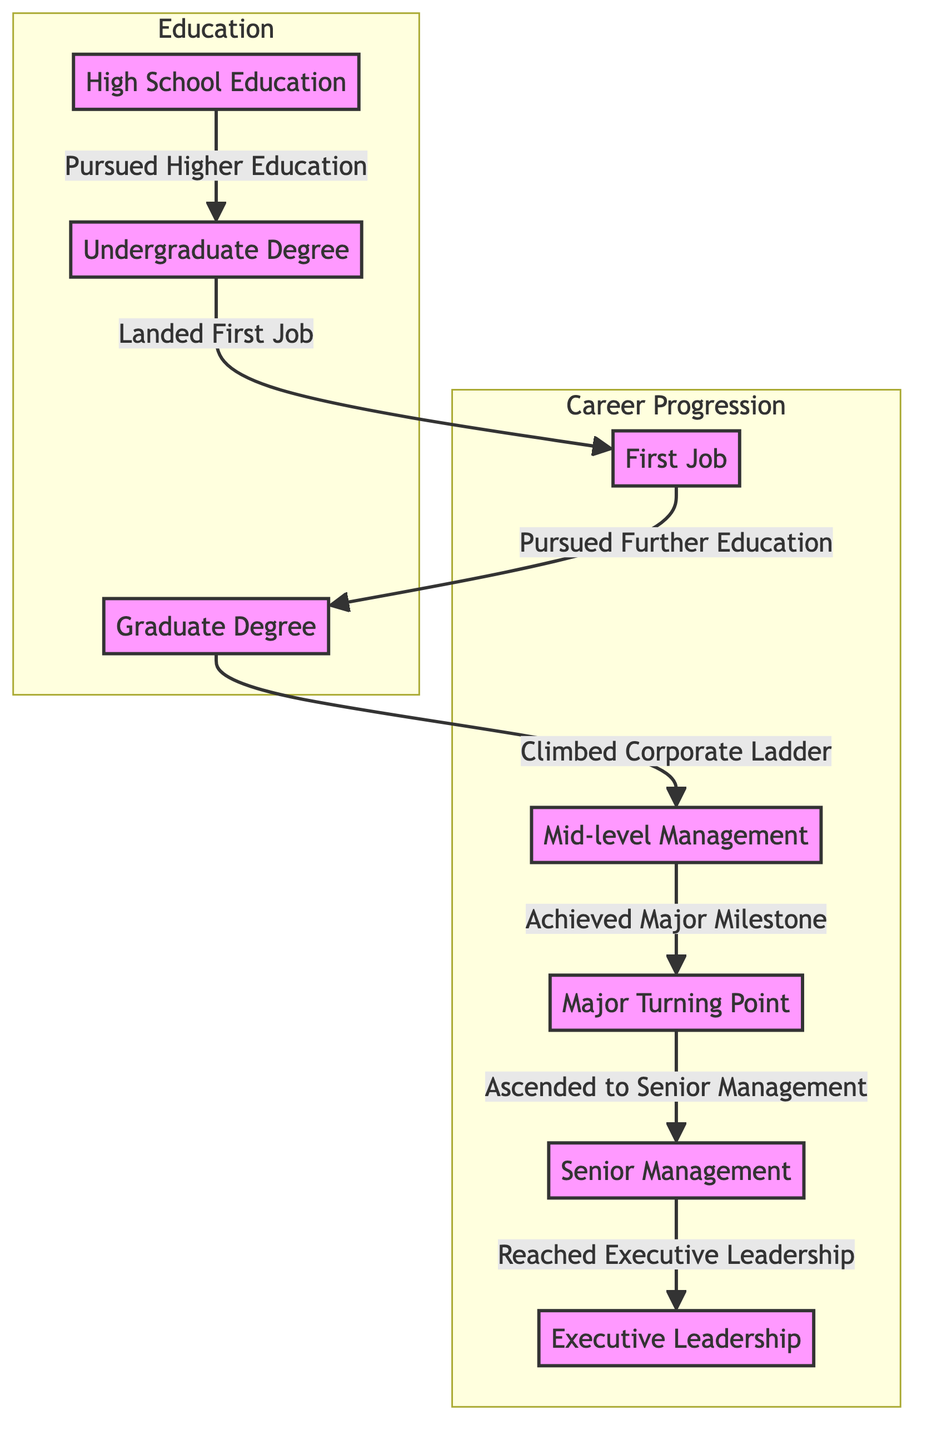What is the starting point of the pathway? The pathway begins at the node labeled "High School Education." This is the first node listed in the diagram, indicating the initial step in the educational journey of the business leaders.
Answer: High School Education How many nodes are there in the diagram? The diagram contains a total of eight nodes representing different stages of education and career progression. By counting the distinct boxes in the flowchart, we determine there are eight.
Answer: 8 What role comes immediately after "First Job"? After the "First Job" node, the pathway directs to "Graduate Degree," indicating that pursuing further education follows the first job in the career progression.
Answer: Graduate Degree What is the major turning point in the progression? The major turning point in the career progression is represented by the node labeled "Major Turning Point." This indicates a significant event or decision in a leader's career trajectory.
Answer: Major Turning Point What educational level precedes mid-level management? The educational level that comes before "Mid-level Management" is "Graduate Degree." This shows the necessity of further education before advancing to mid-level positions.
Answer: Graduate Degree How does one achieve senior management? To reach "Senior Management," one must first experience a "Major Turning Point," which indicates an influential moment in their career that enables their ascension to higher levels of management.
Answer: Major Turning Point How many paths lead to executive leadership? There is one direct path that leads to "Executive Leadership," which follows a specific sequence starting from "High School Education" through various stages, culminating in executive leadership after "Senior Management."
Answer: 1 What is the last step in the leadership pathway? The last step in the leadership pathway is represented by the node "Executive Leadership," indicating that this is the final destination in the career progression of these business leaders.
Answer: Executive Leadership 